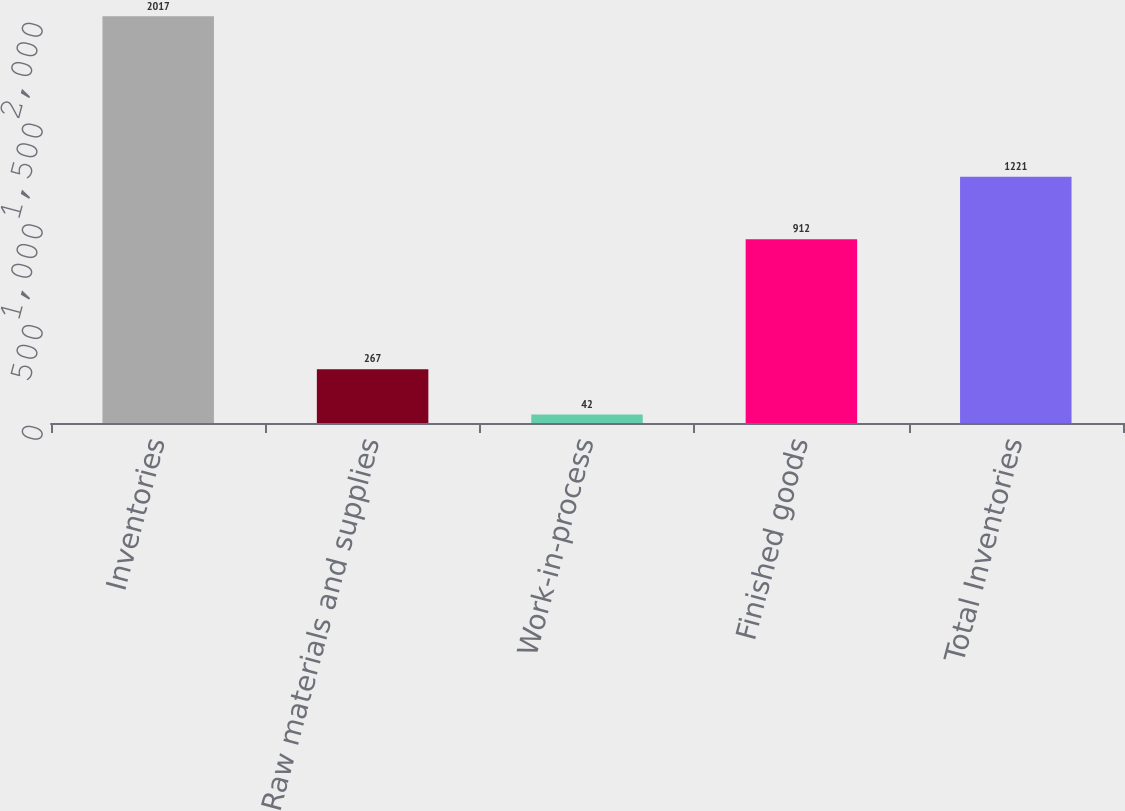<chart> <loc_0><loc_0><loc_500><loc_500><bar_chart><fcel>Inventories<fcel>Raw materials and supplies<fcel>Work-in-process<fcel>Finished goods<fcel>Total Inventories<nl><fcel>2017<fcel>267<fcel>42<fcel>912<fcel>1221<nl></chart> 